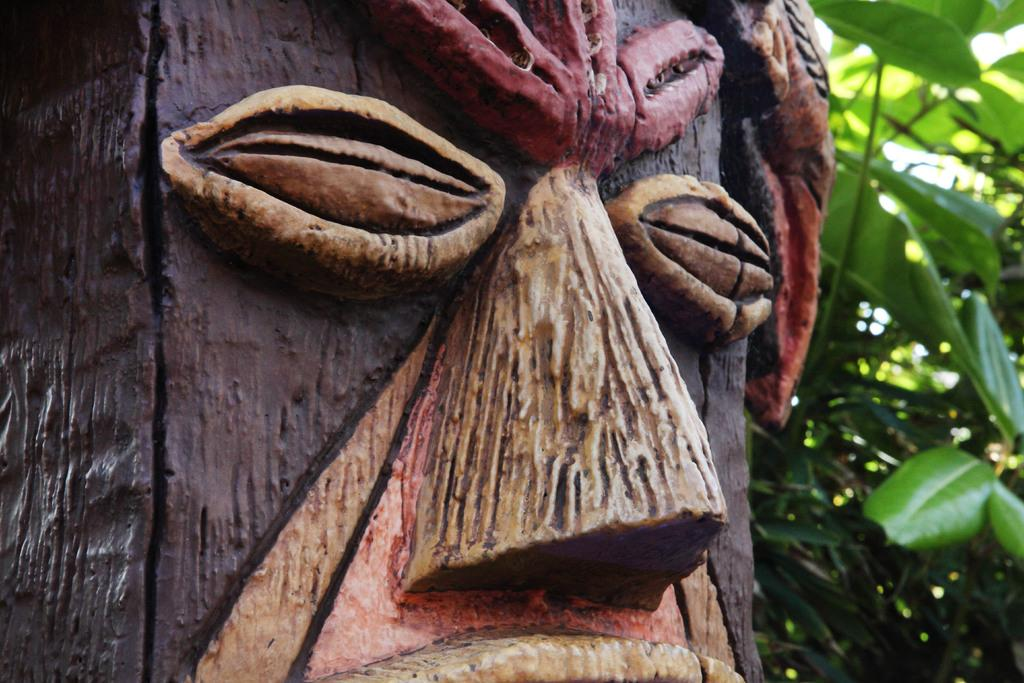What type of art is featured in the image? There is a wooden art of a face in the image. What does the wooden art represent? The wooden art is of a human face. What other elements are present in the image besides the wooden art? There are plants in the image. What is the color of the plants in the image? The plants are green in color. Can you see the army marching in the image? There is no army or marching depicted in the image; it features a wooden art of a human face and green plants. 